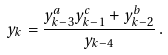Convert formula to latex. <formula><loc_0><loc_0><loc_500><loc_500>y _ { k } = \frac { y _ { k - 3 } ^ { a } y _ { k - 1 } ^ { c } + y _ { k - 2 } ^ { b } } { y _ { k - 4 } } \, .</formula> 